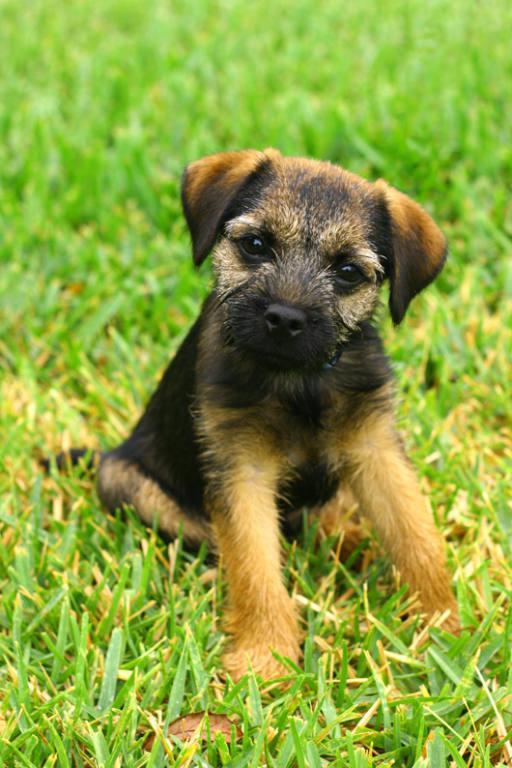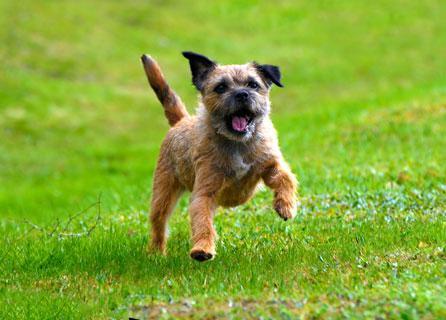The first image is the image on the left, the second image is the image on the right. Evaluate the accuracy of this statement regarding the images: "1 of the dogs has a tail that is in a resting position.". Is it true? Answer yes or no. Yes. The first image is the image on the left, the second image is the image on the right. Evaluate the accuracy of this statement regarding the images: "One dog is wearing a collar or leash, and the other dog is not.". Is it true? Answer yes or no. No. 